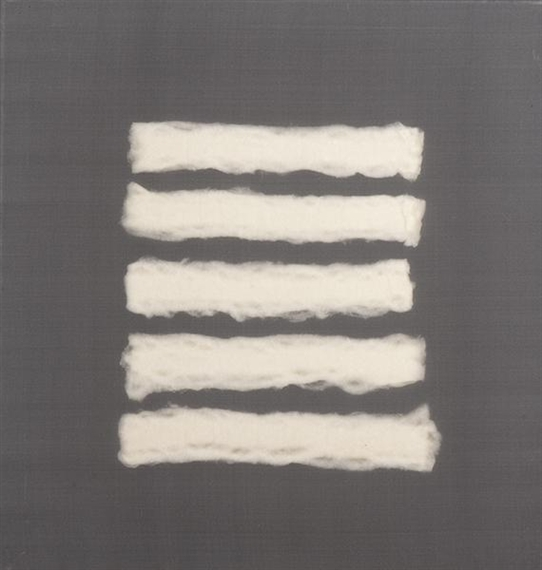What is this photo about? The image showcases a piece of modern abstract art characterized by its minimalist and textured design. The artwork features a soothing gray background, onto which five approximately horizontal white strips have been arranged. These strips are irregular and slightly uneven, adding a dynamic sense of spontaneity and texture to the piece. The texture of these white lines suggests they could be reminiscent of soft materials like cotton or wool. The overall aesthetic aligns with abstract expressionism, focusing more on evoking emotion and subjective experience rather than depicting a concrete object or scene. The choice of a limited color palette and the bold, yet soft contrasts help in creating a visually compelling and thought-provoking artwork. 